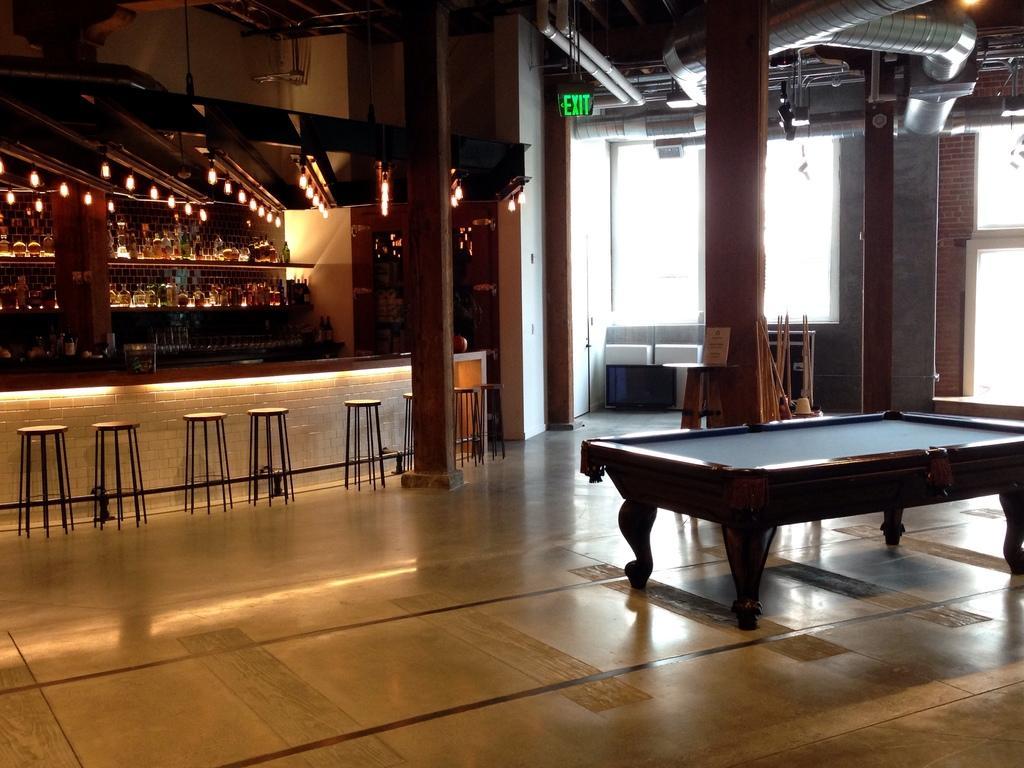Can you describe this image briefly? there is a table in the front. behind that there are stools. at the back there are shelves. above that there are lights. a exit sign board is on the top and at the right there is a window. 